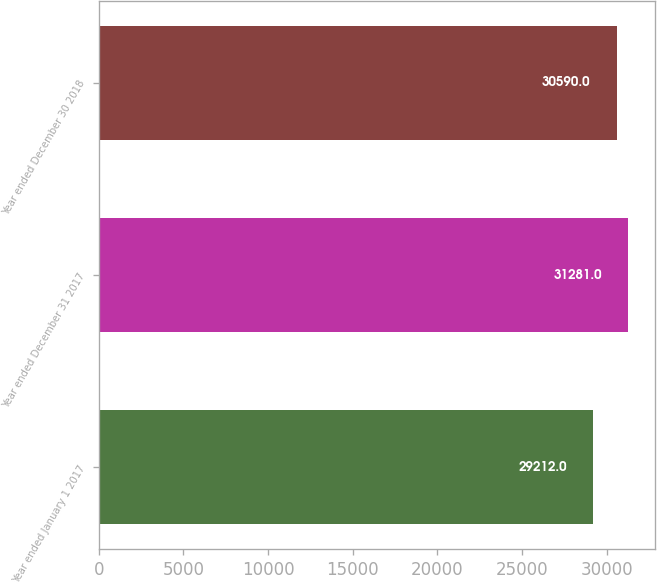<chart> <loc_0><loc_0><loc_500><loc_500><bar_chart><fcel>Year ended January 1 2017<fcel>Year ended December 31 2017<fcel>Year ended December 30 2018<nl><fcel>29212<fcel>31281<fcel>30590<nl></chart> 